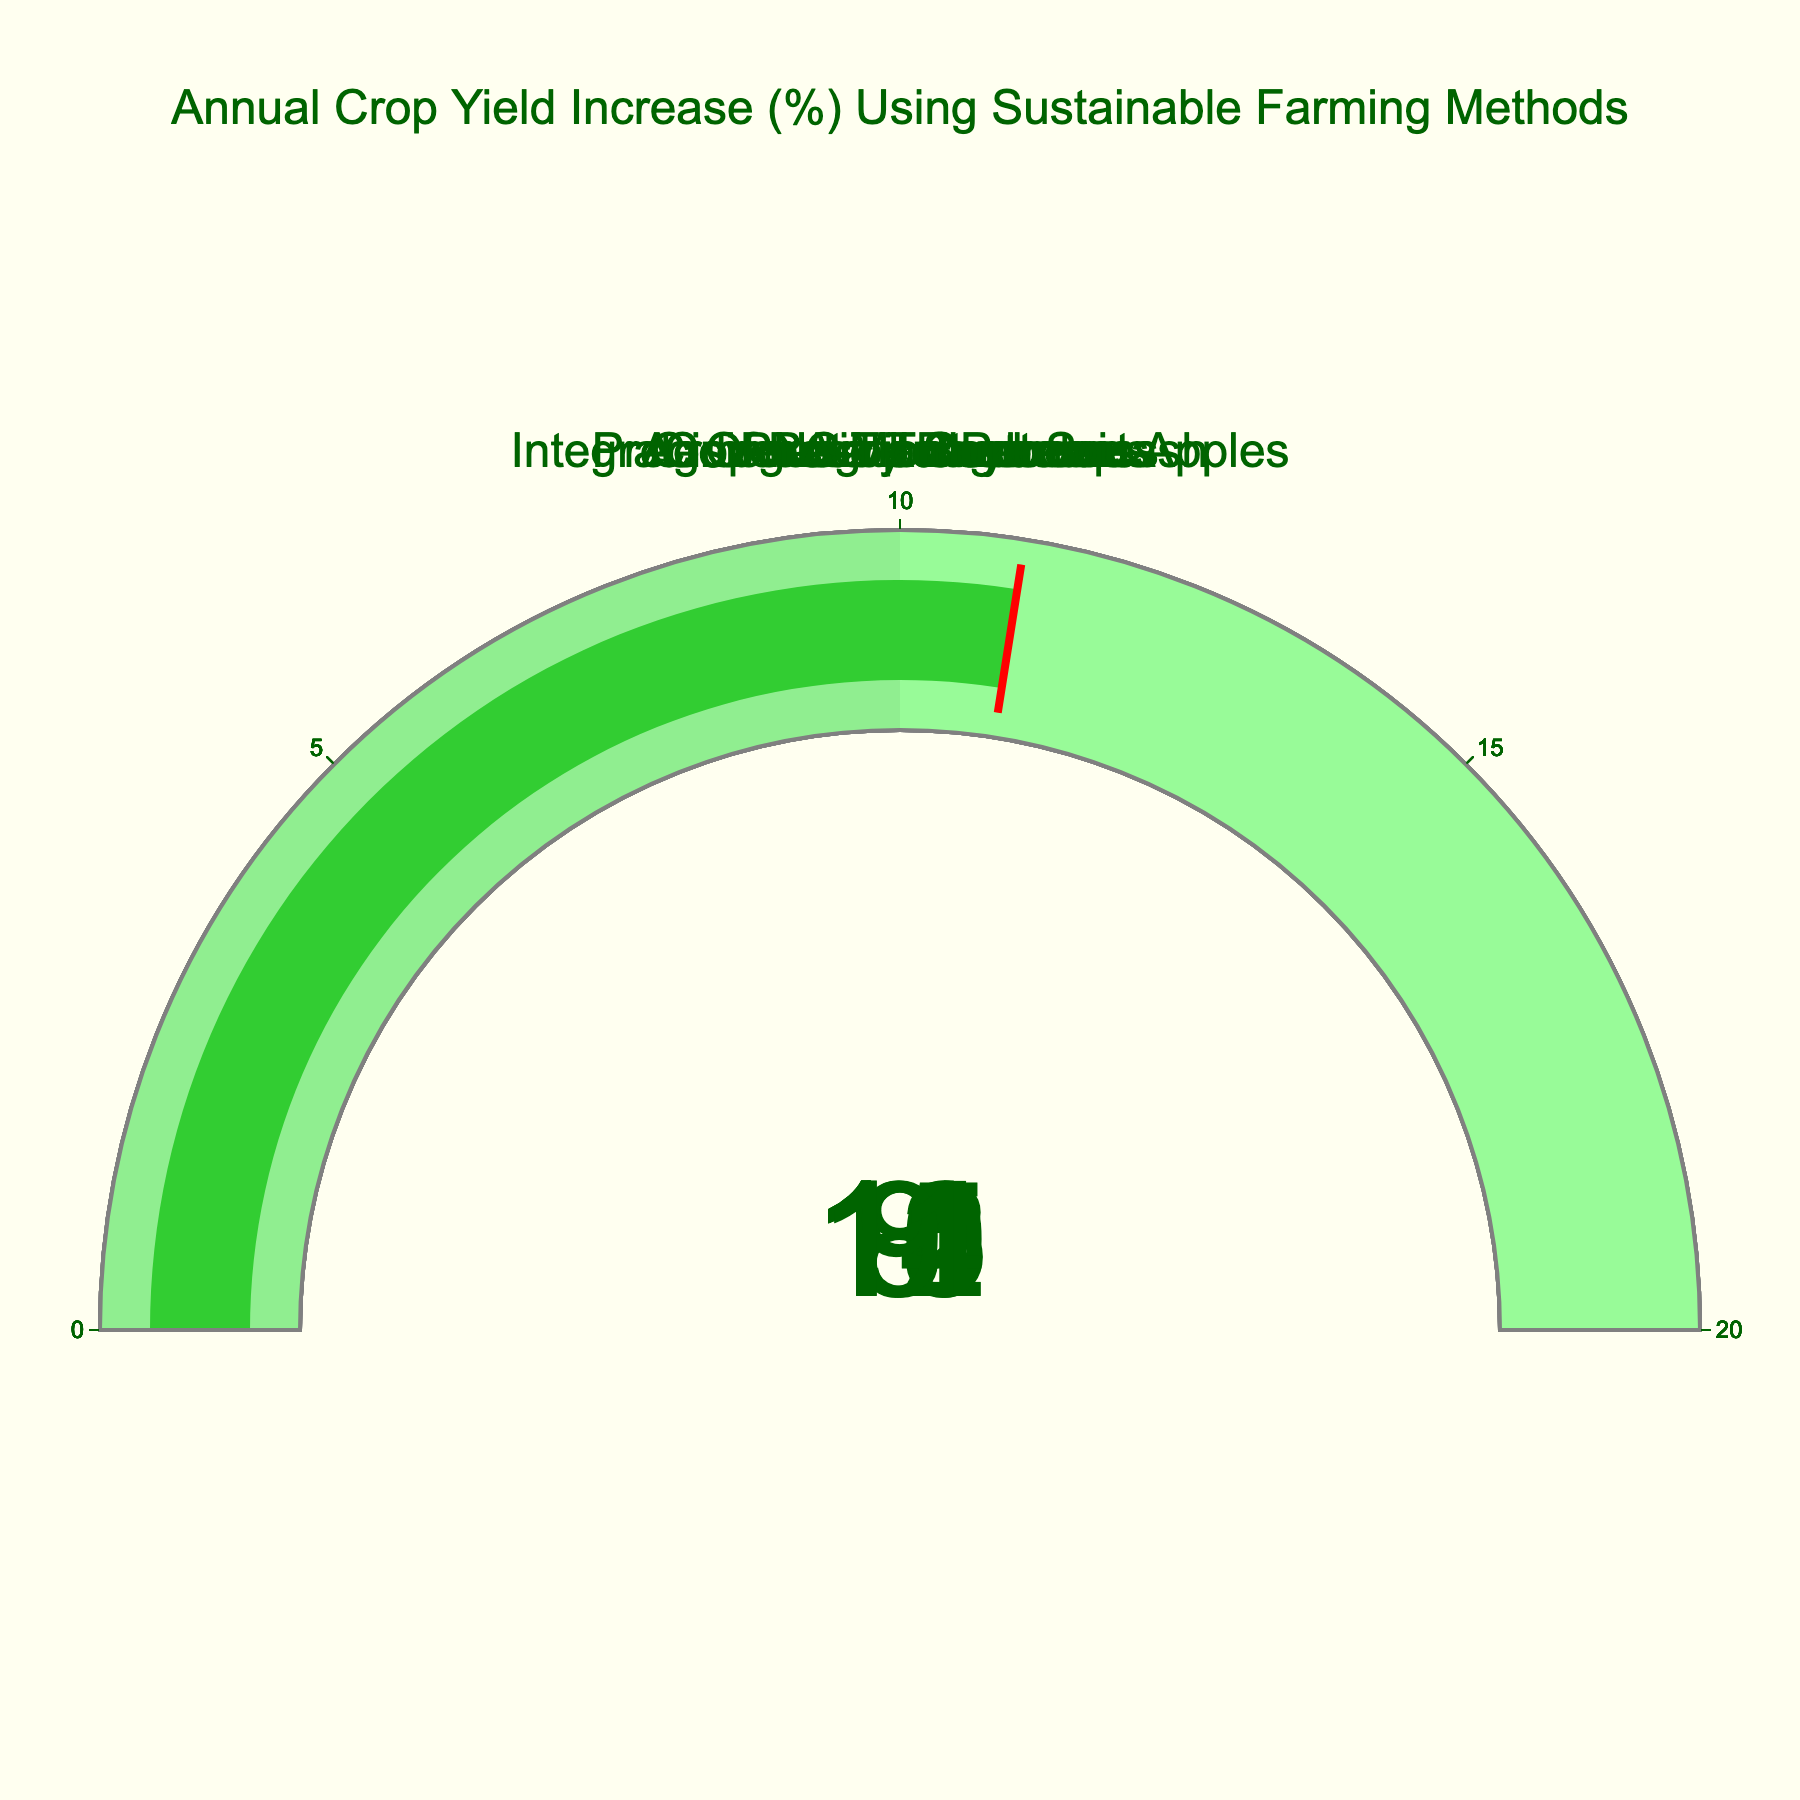Which crop has the highest yield increase percentage? To determine which crop has the highest yield increase percentage, look at each gauge and identify the largest percentage value. The Cover Crop Soybeans gauge shows 15%, which is the highest among all crops.
Answer: Cover Crop Soybeans Which crop has the lowest yield increase percentage? To find the crop with the lowest yield increase percentage, look at each gauge and identify the smallest percentage value. The No-Till Corn gauge shows 8%, which is the lowest among all crops.
Answer: No-Till Corn What is the difference in yield increase percentage between Crop Rotation Potatoes and Agroforestry Blueberries? Identify the yield increase percentages for Crop Rotation Potatoes (14%) and Agroforestry Blueberries (9%). Subtract 9 from 14 to find the difference.
Answer: 5 What is the average yield increase percentage of all crops? Add all the yield increase percentages: 12 (Organic Tomatoes) + 8 (No-Till Corn) + 15 (Cover Crop Soybeans) + 10 (Integrated Pest Management Apples) + 14 (Crop Rotation Potatoes) + 9 (Agroforestry Blueberries) + 11 (Precision Agriculture Squash) = 79. There are 7 crops, so divide 79 by 7.
Answer: 11.29 Which crop's yield increase percentage is closest to the overall average yield increase percentage? First, calculate the average yield increase percentage (11.29%). Then find the differences between this average and each crop's yield increase percentage. The Precision Agriculture Squash has a yield increase of 11%, which is the closest to the average of 11.29%.
Answer: Precision Agriculture Squash How many crops have a yield increase percentage greater than or equal to 10? Check each crop's yield increase percentage and count how many are 10% or higher. Organic Tomatoes (12%), Cover Crop Soybeans (15%), Integrated Pest Management Apples (10%), Crop Rotation Potatoes (14%), and Precision Agriculture Squash (11%) meet this criterion. That's 5 crops.
Answer: 5 